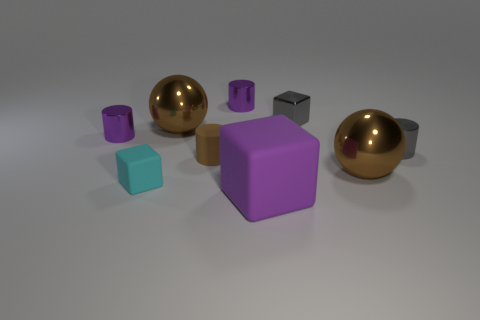Subtract all red cylinders. Subtract all blue blocks. How many cylinders are left? 4 Subtract all blocks. How many objects are left? 6 Subtract 1 brown cylinders. How many objects are left? 8 Subtract all tiny gray objects. Subtract all brown rubber things. How many objects are left? 6 Add 6 big matte blocks. How many big matte blocks are left? 7 Add 7 gray metallic blocks. How many gray metallic blocks exist? 8 